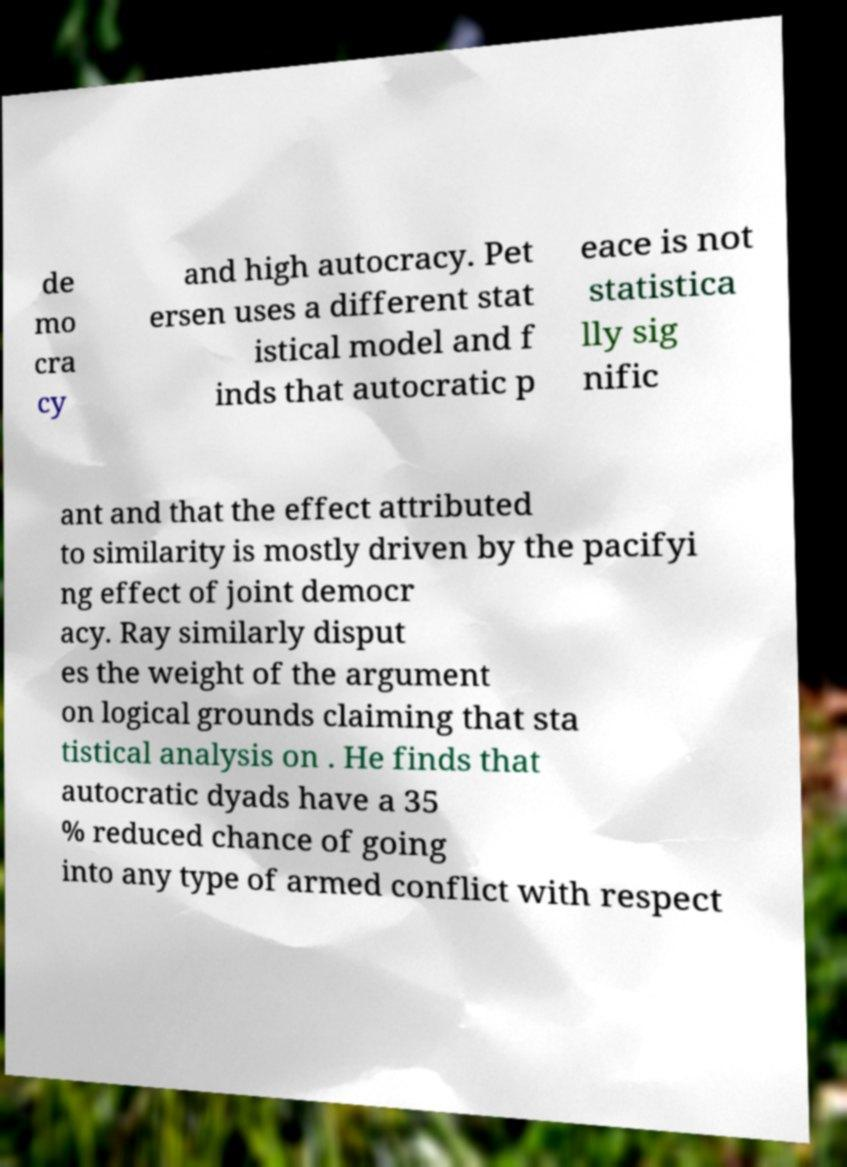Could you extract and type out the text from this image? de mo cra cy and high autocracy. Pet ersen uses a different stat istical model and f inds that autocratic p eace is not statistica lly sig nific ant and that the effect attributed to similarity is mostly driven by the pacifyi ng effect of joint democr acy. Ray similarly disput es the weight of the argument on logical grounds claiming that sta tistical analysis on . He finds that autocratic dyads have a 35 % reduced chance of going into any type of armed conflict with respect 